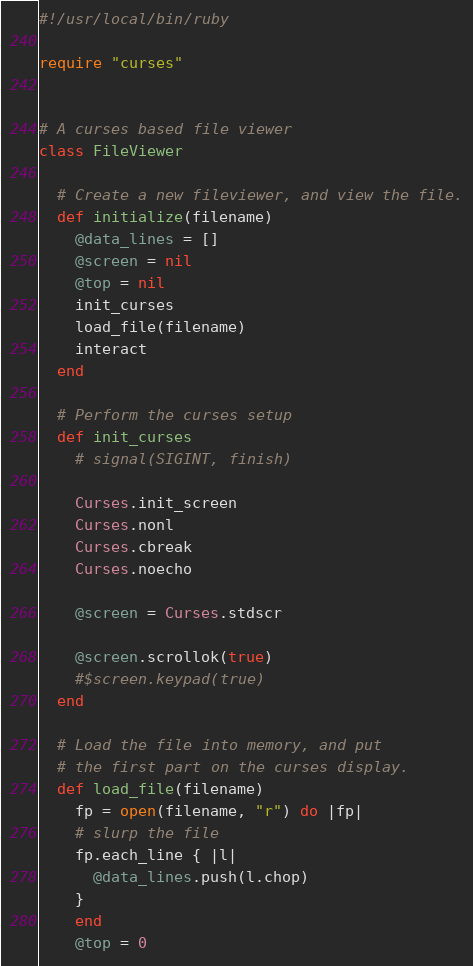Convert code to text. <code><loc_0><loc_0><loc_500><loc_500><_Ruby_>#!/usr/local/bin/ruby

require "curses"


# A curses based file viewer
class FileViewer

  # Create a new fileviewer, and view the file.
  def initialize(filename)
    @data_lines = []
    @screen = nil
    @top = nil
    init_curses
    load_file(filename)
    interact
  end

  # Perform the curses setup
  def init_curses
    # signal(SIGINT, finish)

    Curses.init_screen
    Curses.nonl
    Curses.cbreak
    Curses.noecho

    @screen = Curses.stdscr

    @screen.scrollok(true)
    #$screen.keypad(true)
  end

  # Load the file into memory, and put
  # the first part on the curses display.
  def load_file(filename)
    fp = open(filename, "r") do |fp|
    # slurp the file
    fp.each_line { |l|
      @data_lines.push(l.chop)
    }
    end
    @top = 0</code> 